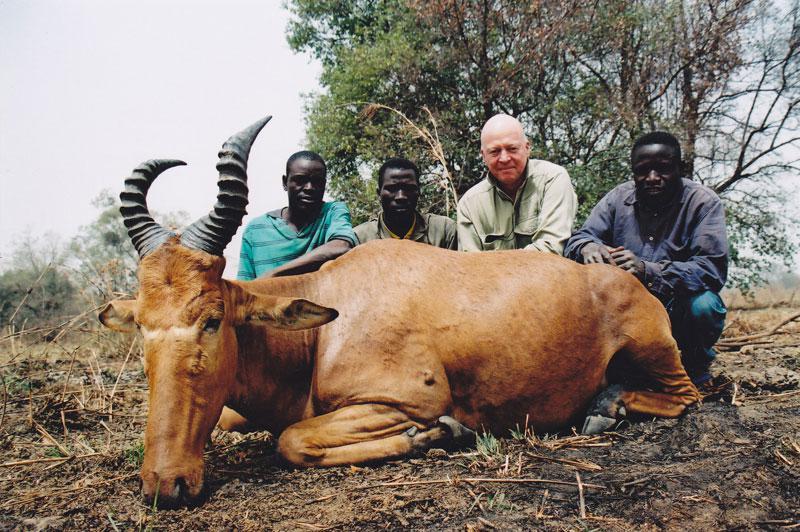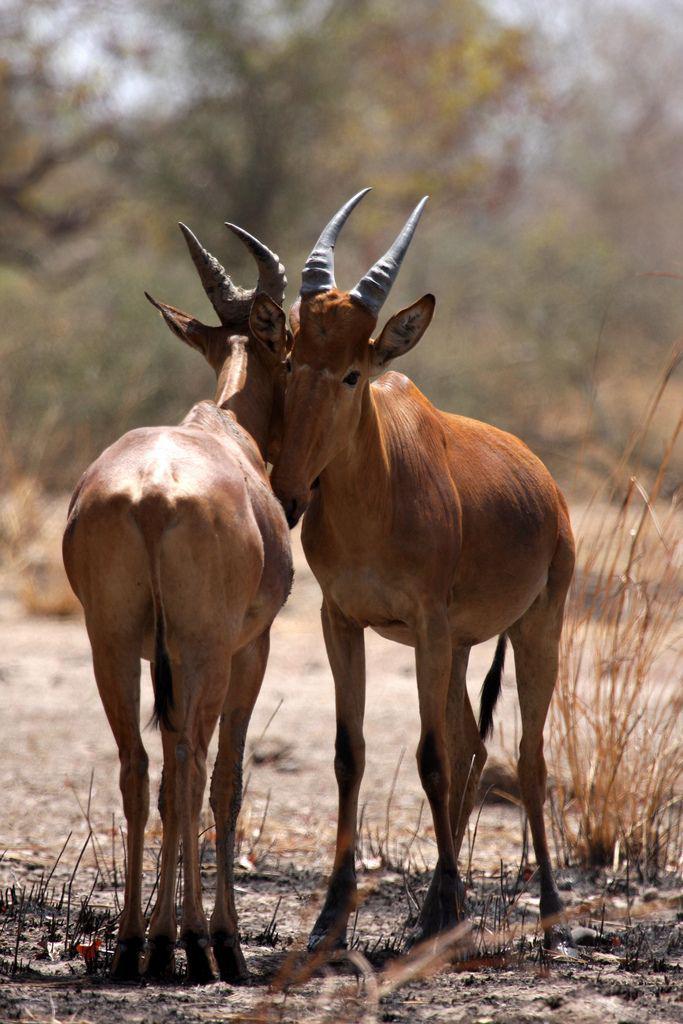The first image is the image on the left, the second image is the image on the right. Assess this claim about the two images: "In at least one image, animals are drinking water.". Correct or not? Answer yes or no. No. 